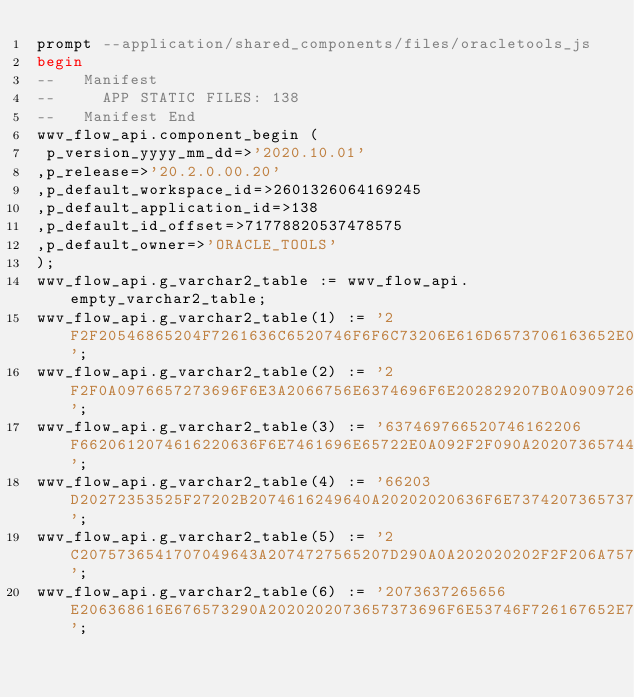<code> <loc_0><loc_0><loc_500><loc_500><_SQL_>prompt --application/shared_components/files/oracletools_js
begin
--   Manifest
--     APP STATIC FILES: 138
--   Manifest End
wwv_flow_api.component_begin (
 p_version_yyyy_mm_dd=>'2020.10.01'
,p_release=>'20.2.0.00.20'
,p_default_workspace_id=>2601326064169245
,p_default_application_id=>138
,p_default_id_offset=>71778820537478575
,p_default_owner=>'ORACLE_TOOLS'
);
wwv_flow_api.g_varchar2_table := wwv_flow_api.empty_varchar2_table;
wwv_flow_api.g_varchar2_table(1) := '2F2F20546865204F7261636C6520746F6F6C73206E616D6573706163652E0A766172206F7261636C65546F6F6C73203D207B0A092F2F090A092F2F2052657475726E207468652076657273696F6E206F662074686973206E616D657370616365092E0A09';
wwv_flow_api.g_varchar2_table(2) := '2F2F0A0976657273696F6E3A2066756E6374696F6E202829207B0A090972657475726E2027323032302D31322D31362031333A3035273B202F2F207979792D6D6D2D646420686832343A6D690A097D2C0A0A092F2F090A092F2F20536574207468652061';
wwv_flow_api.g_varchar2_table(3) := '637469766520746162206F6620612074616220636F6E7461696E65722E0A092F2F090A20207365744163746976655461623A2066756E6374696F6E202874616273436F6E7461696E657249642C20746162496429207B0A20202020636F6E737420687265';
wwv_flow_api.g_varchar2_table(4) := '66203D20272353525F27202B2074616249640A20202020636F6E73742073657373696F6E53746F72616765203D20617065782E73746F726167652E67657453636F70656453657373696F6E53746F72616765287B207573655061676549643A2074727565';
wwv_flow_api.g_varchar2_table(5) := '2C2075736541707049643A2074727565207D290A0A202020202F2F206A75737420636163686520746865206E657720726567696F6E20746F20676F20746F2062757420646F206E6F742073776974636820746F206974207965742028746F6F206D616E79';
wwv_flow_api.g_varchar2_table(6) := '2073637265656E206368616E676573290A2020202073657373696F6E53746F726167652E7365744974656D2874616273436F6E7461696E65724964202B20272E616374697665546162272C2068726566290A20207D2C0A0A092F2F090A092F2F20476574';</code> 